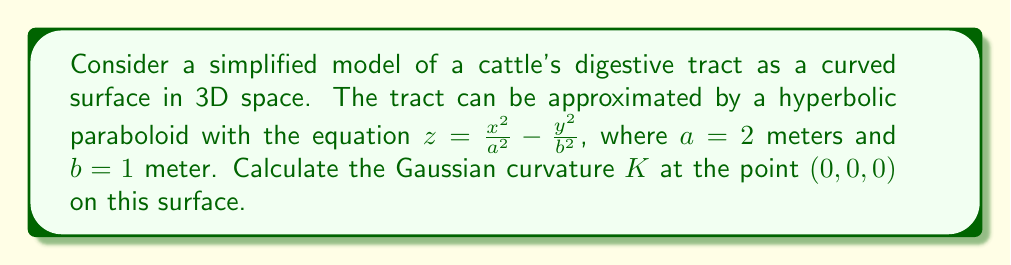Could you help me with this problem? To find the Gaussian curvature $K$ at the point $(0, 0, 0)$ on the hyperbolic paraboloid surface, we'll follow these steps:

1) The Gaussian curvature $K$ is given by $K = \kappa_1 \kappa_2$, where $\kappa_1$ and $\kappa_2$ are the principal curvatures.

2) For a surface $z = f(x,y)$, the Gaussian curvature at a point $(x, y, z)$ is given by:

   $$K = \frac{f_{xx}f_{yy} - f_{xy}^2}{(1 + f_x^2 + f_y^2)^2}$$

   where subscripts denote partial derivatives.

3) For our surface $z = \frac{x^2}{a^2} - \frac{y^2}{b^2}$, we need to calculate:

   $f_x = \frac{2x}{a^2}$
   $f_y = -\frac{2y}{b^2}$
   $f_{xx} = \frac{2}{a^2}$
   $f_{yy} = -\frac{2}{b^2}$
   $f_{xy} = 0$

4) At the point $(0, 0, 0)$, $f_x = f_y = 0$, so our equation simplifies to:

   $$K = f_{xx}f_{yy} - f_{xy}^2$$

5) Substituting the values:

   $$K = (\frac{2}{a^2})(-\frac{2}{b^2}) - 0^2 = -\frac{4}{a^2b^2}$$

6) Now, we can plug in $a = 2$ and $b = 1$:

   $$K = -\frac{4}{(2)^2(1)^2} = -\frac{4}{4} = -1$$

Therefore, the Gaussian curvature $K$ at the point $(0, 0, 0)$ is $-1$ m^(-2).
Answer: $-1$ m^(-2) 